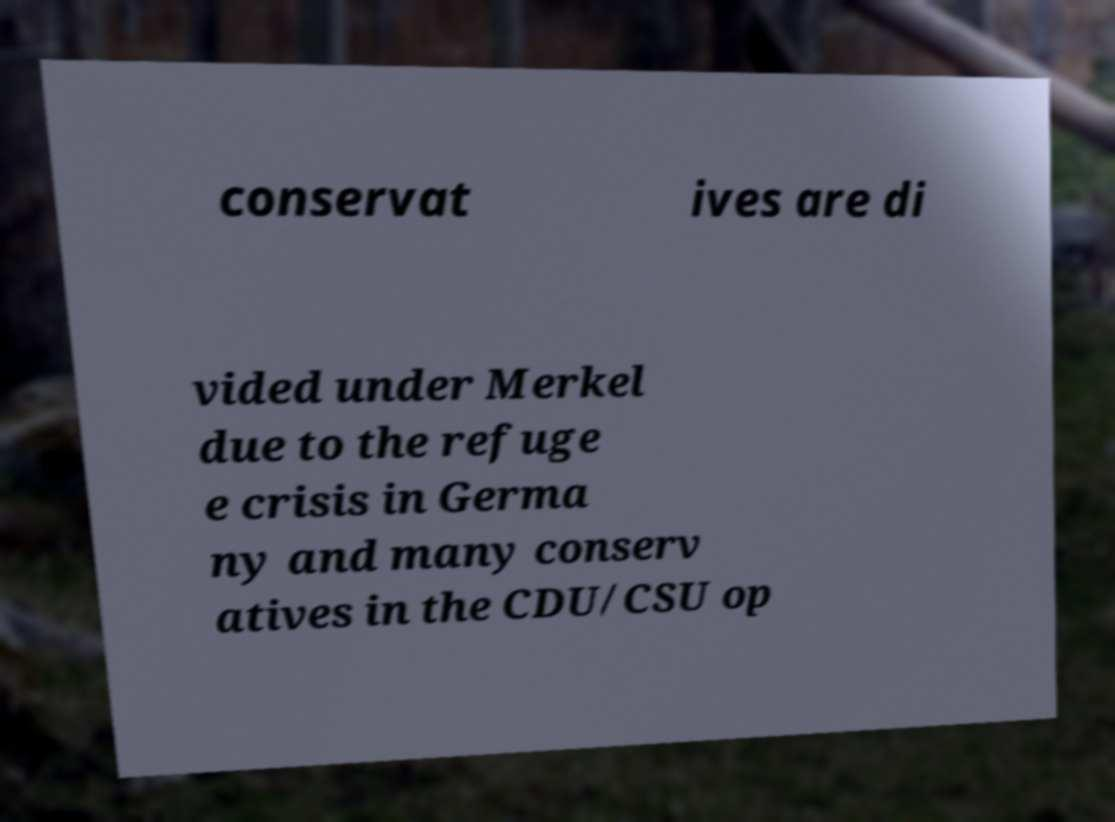Could you assist in decoding the text presented in this image and type it out clearly? conservat ives are di vided under Merkel due to the refuge e crisis in Germa ny and many conserv atives in the CDU/CSU op 